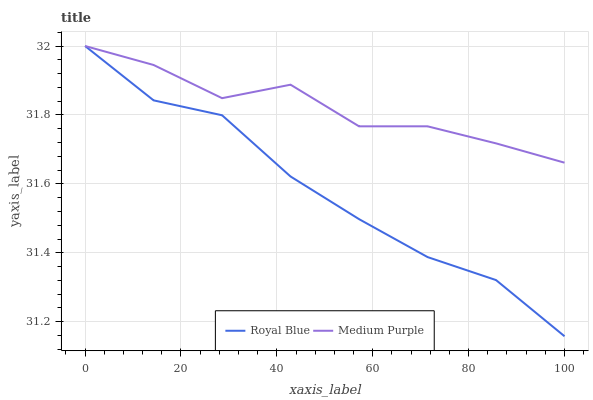Does Royal Blue have the minimum area under the curve?
Answer yes or no. Yes. Does Medium Purple have the maximum area under the curve?
Answer yes or no. Yes. Does Royal Blue have the maximum area under the curve?
Answer yes or no. No. Is Royal Blue the smoothest?
Answer yes or no. Yes. Is Medium Purple the roughest?
Answer yes or no. Yes. Is Royal Blue the roughest?
Answer yes or no. No. Does Royal Blue have the lowest value?
Answer yes or no. Yes. Does Royal Blue have the highest value?
Answer yes or no. Yes. Does Medium Purple intersect Royal Blue?
Answer yes or no. Yes. Is Medium Purple less than Royal Blue?
Answer yes or no. No. Is Medium Purple greater than Royal Blue?
Answer yes or no. No. 